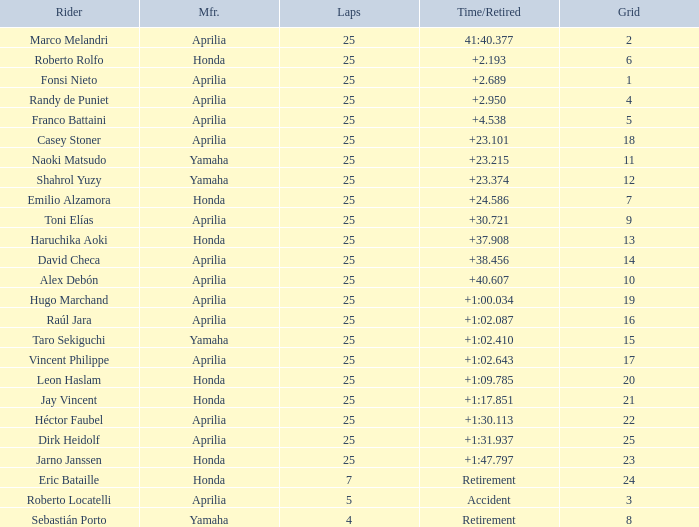Which Grid has Laps of 25, and a Manufacturer of honda, and a Time/Retired of +1:47.797? 23.0. 